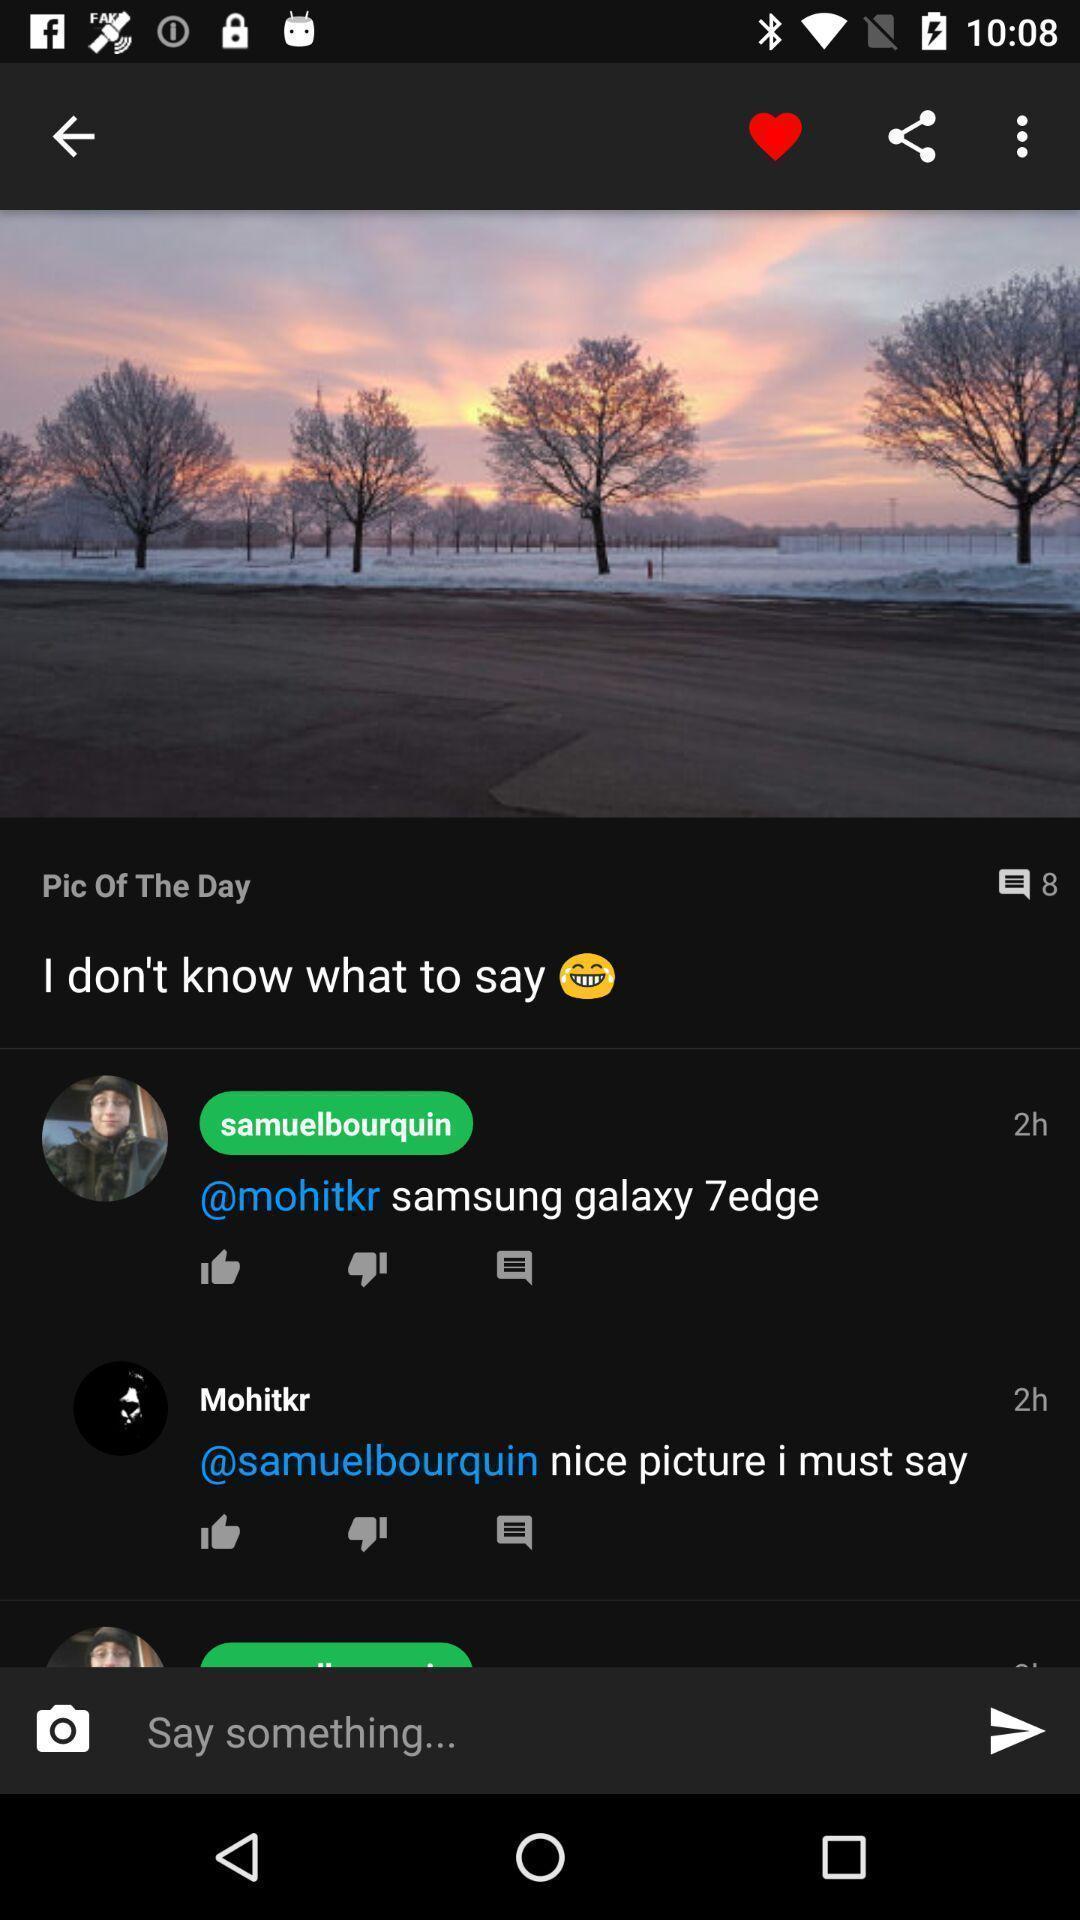What can you discern from this picture? Page displaying pic of the day with reviews. 